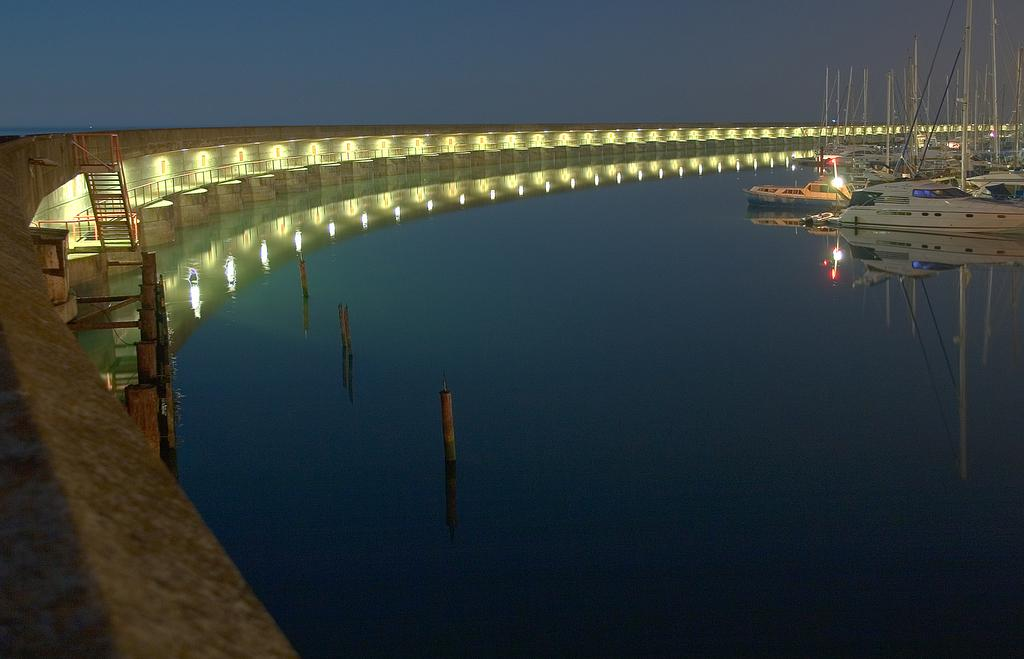What type of vehicles are in the water in the image? There are ships in the water in the image. What else can be seen in the water besides the ships? There are poles in the water. What can be seen in the image that provides illumination? There are lights visible in the image. How many times did the ships kiss each other in the image? There is no indication of ships kissing each other in the image; they are simply floating in the water. 